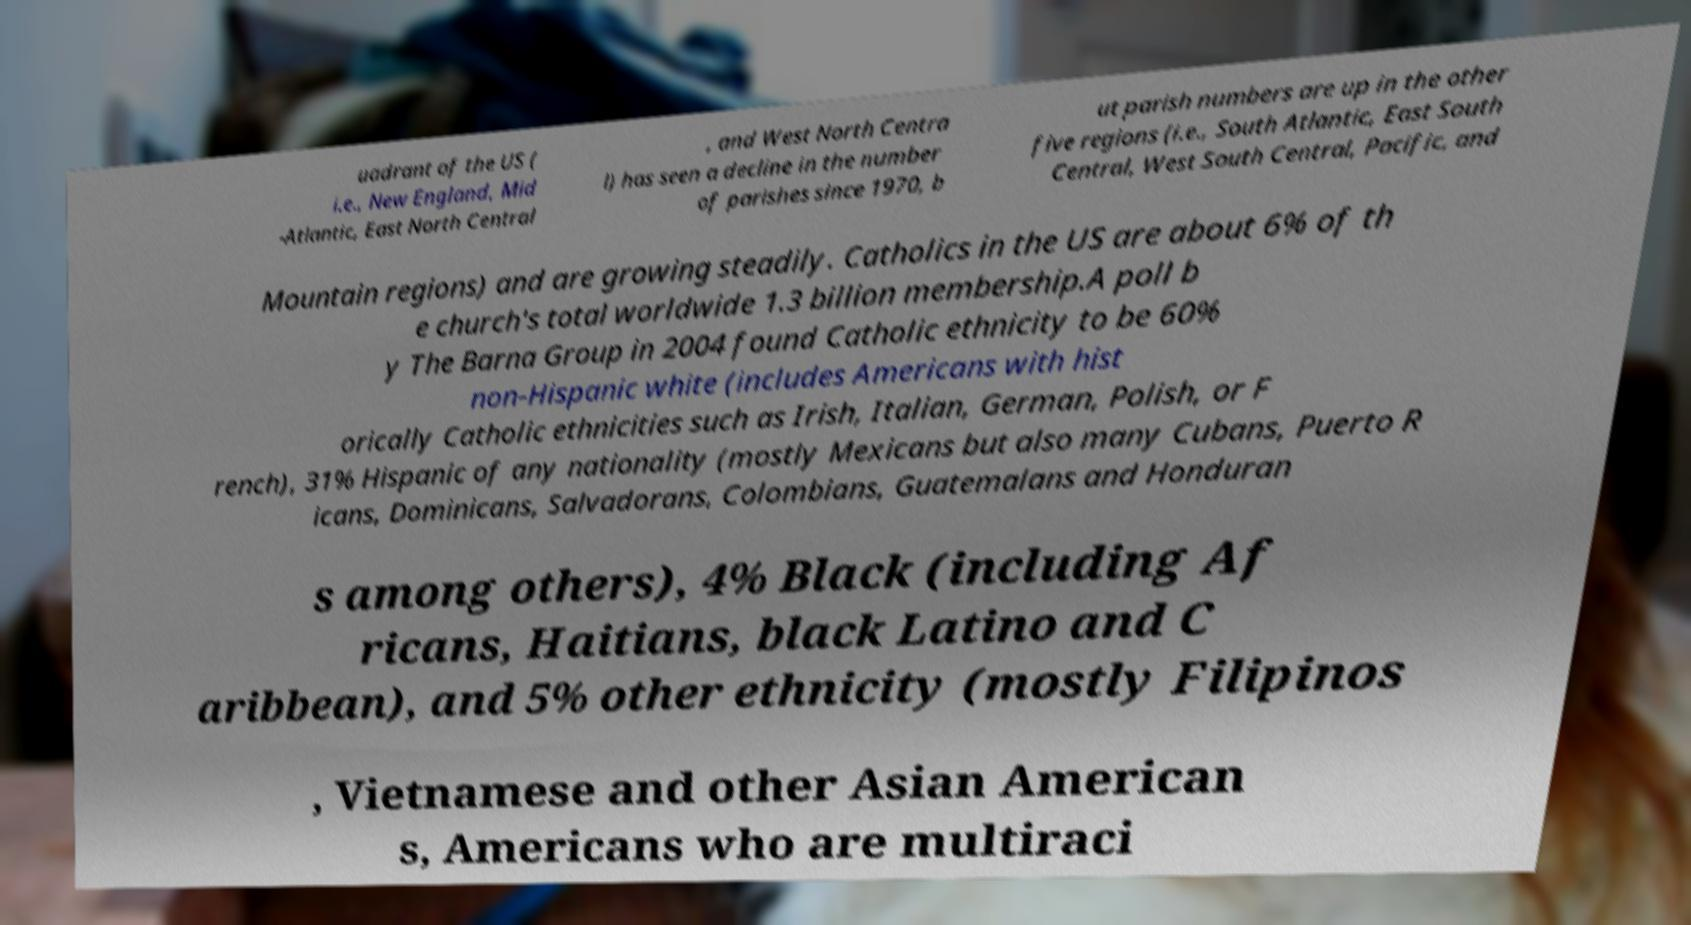Could you assist in decoding the text presented in this image and type it out clearly? uadrant of the US ( i.e., New England, Mid -Atlantic, East North Central , and West North Centra l) has seen a decline in the number of parishes since 1970, b ut parish numbers are up in the other five regions (i.e., South Atlantic, East South Central, West South Central, Pacific, and Mountain regions) and are growing steadily. Catholics in the US are about 6% of th e church's total worldwide 1.3 billion membership.A poll b y The Barna Group in 2004 found Catholic ethnicity to be 60% non-Hispanic white (includes Americans with hist orically Catholic ethnicities such as Irish, Italian, German, Polish, or F rench), 31% Hispanic of any nationality (mostly Mexicans but also many Cubans, Puerto R icans, Dominicans, Salvadorans, Colombians, Guatemalans and Honduran s among others), 4% Black (including Af ricans, Haitians, black Latino and C aribbean), and 5% other ethnicity (mostly Filipinos , Vietnamese and other Asian American s, Americans who are multiraci 